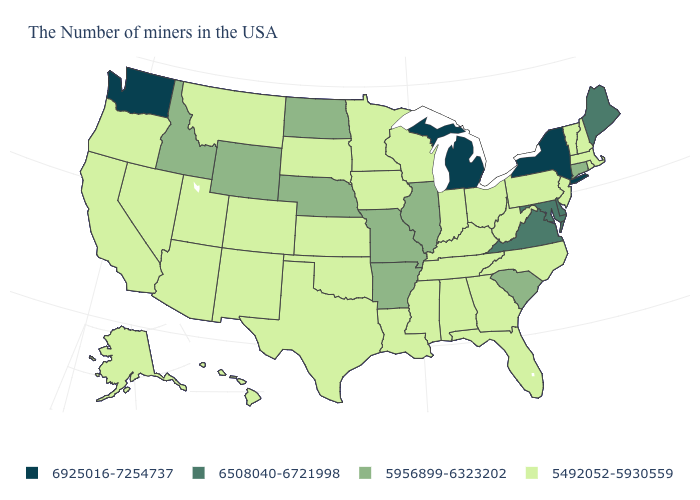Does New Jersey have a higher value than Connecticut?
Answer briefly. No. Among the states that border Virginia , which have the lowest value?
Quick response, please. North Carolina, West Virginia, Kentucky, Tennessee. Which states hav the highest value in the MidWest?
Quick response, please. Michigan. Which states have the highest value in the USA?
Be succinct. New York, Michigan, Washington. Among the states that border New Jersey , does Delaware have the highest value?
Give a very brief answer. No. What is the value of Hawaii?
Quick response, please. 5492052-5930559. What is the value of Montana?
Short answer required. 5492052-5930559. Among the states that border Wyoming , which have the highest value?
Answer briefly. Nebraska, Idaho. Name the states that have a value in the range 6508040-6721998?
Concise answer only. Maine, Delaware, Maryland, Virginia. Name the states that have a value in the range 5492052-5930559?
Be succinct. Massachusetts, Rhode Island, New Hampshire, Vermont, New Jersey, Pennsylvania, North Carolina, West Virginia, Ohio, Florida, Georgia, Kentucky, Indiana, Alabama, Tennessee, Wisconsin, Mississippi, Louisiana, Minnesota, Iowa, Kansas, Oklahoma, Texas, South Dakota, Colorado, New Mexico, Utah, Montana, Arizona, Nevada, California, Oregon, Alaska, Hawaii. What is the value of Pennsylvania?
Be succinct. 5492052-5930559. Which states hav the highest value in the West?
Answer briefly. Washington. Name the states that have a value in the range 5492052-5930559?
Write a very short answer. Massachusetts, Rhode Island, New Hampshire, Vermont, New Jersey, Pennsylvania, North Carolina, West Virginia, Ohio, Florida, Georgia, Kentucky, Indiana, Alabama, Tennessee, Wisconsin, Mississippi, Louisiana, Minnesota, Iowa, Kansas, Oklahoma, Texas, South Dakota, Colorado, New Mexico, Utah, Montana, Arizona, Nevada, California, Oregon, Alaska, Hawaii. What is the value of North Dakota?
Give a very brief answer. 5956899-6323202. Among the states that border Indiana , which have the lowest value?
Quick response, please. Ohio, Kentucky. 